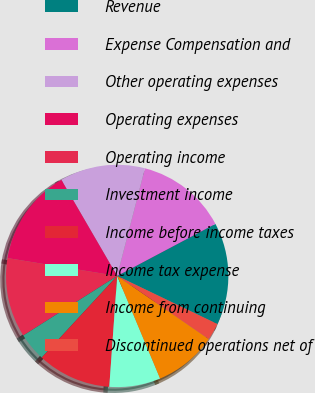Convert chart. <chart><loc_0><loc_0><loc_500><loc_500><pie_chart><fcel>Revenue<fcel>Expense Compensation and<fcel>Other operating expenses<fcel>Operating expenses<fcel>Operating income<fcel>Investment income<fcel>Income before income taxes<fcel>Income tax expense<fcel>Income from continuing<fcel>Discontinued operations net of<nl><fcel>14.88%<fcel>13.22%<fcel>12.4%<fcel>14.05%<fcel>11.57%<fcel>4.13%<fcel>10.74%<fcel>7.44%<fcel>9.09%<fcel>2.48%<nl></chart> 